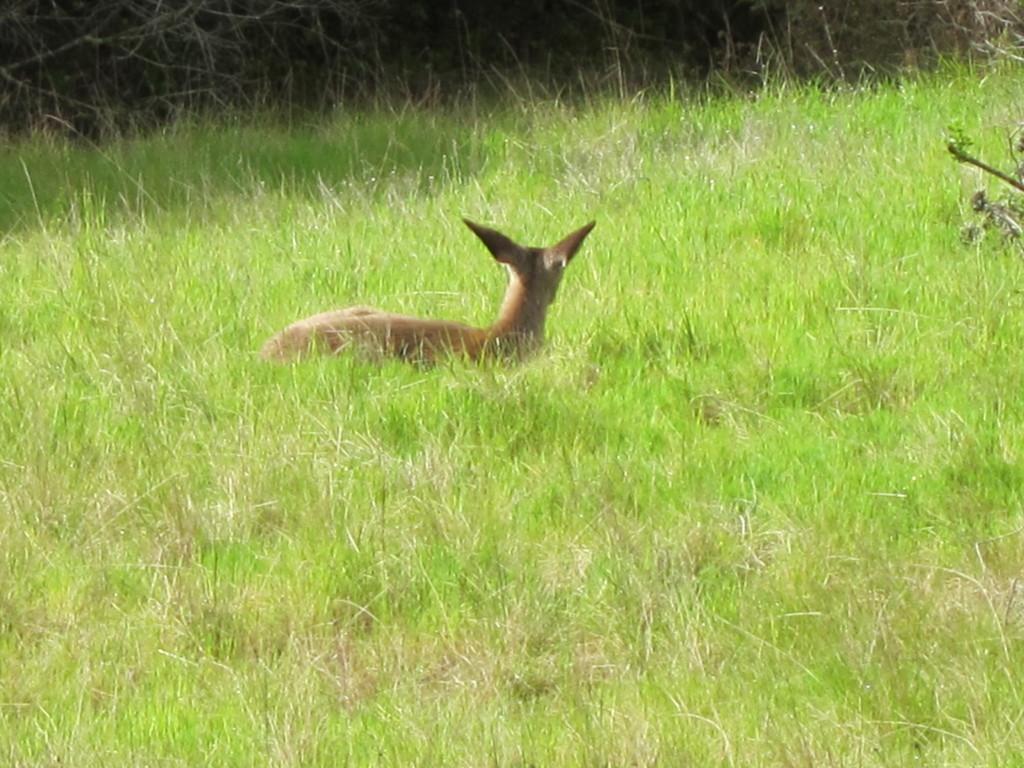Describe this image in one or two sentences. An animal is sitting in this green color grass. 